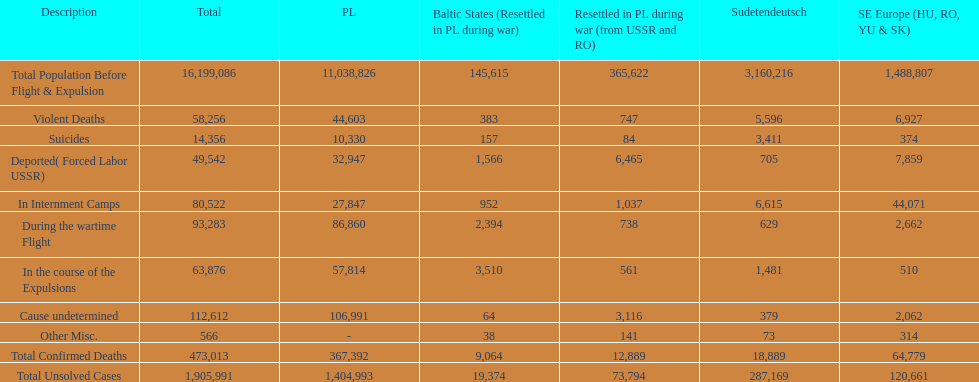How many causes were responsible for more than 50,000 confirmed deaths? 5. Can you parse all the data within this table? {'header': ['Description', 'Total', 'PL', 'Baltic States (Resettled in PL during war)', 'Resettled in PL during war (from USSR and RO)', 'Sudetendeutsch', 'SE Europe (HU, RO, YU & SK)'], 'rows': [['Total Population Before Flight & Expulsion', '16,199,086', '11,038,826', '145,615', '365,622', '3,160,216', '1,488,807'], ['Violent Deaths', '58,256', '44,603', '383', '747', '5,596', '6,927'], ['Suicides', '14,356', '10,330', '157', '84', '3,411', '374'], ['Deported( Forced Labor USSR)', '49,542', '32,947', '1,566', '6,465', '705', '7,859'], ['In Internment Camps', '80,522', '27,847', '952', '1,037', '6,615', '44,071'], ['During the wartime Flight', '93,283', '86,860', '2,394', '738', '629', '2,662'], ['In the course of the Expulsions', '63,876', '57,814', '3,510', '561', '1,481', '510'], ['Cause undetermined', '112,612', '106,991', '64', '3,116', '379', '2,062'], ['Other Misc.', '566', '-', '38', '141', '73', '314'], ['Total Confirmed Deaths', '473,013', '367,392', '9,064', '12,889', '18,889', '64,779'], ['Total Unsolved Cases', '1,905,991', '1,404,993', '19,374', '73,794', '287,169', '120,661']]} 